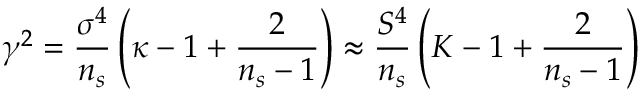Convert formula to latex. <formula><loc_0><loc_0><loc_500><loc_500>\gamma ^ { 2 } = \frac { \sigma ^ { 4 } } { n _ { s } } \left ( \kappa - 1 + \frac { 2 } { n _ { s } - 1 } \right ) \approx \frac { S ^ { 4 } } { n _ { s } } \left ( K - 1 + \frac { 2 } { n _ { s } - 1 } \right )</formula> 